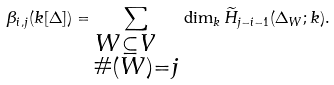<formula> <loc_0><loc_0><loc_500><loc_500>\beta _ { i , j } ( k [ \Delta ] ) = \sum _ { \begin{subarray} { c } W \subseteq V \\ \# ( W ) = j \end{subarray} } \, \dim _ { k } \widetilde { H } _ { j - i - 1 } ( \Delta _ { W } ; k ) .</formula> 